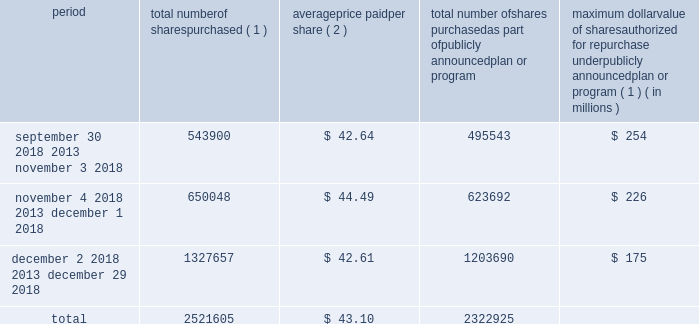Issuer purchases of equity securities in january 2017 , our board of directors authorized the repurchase of shares of our common stock with a value of up to $ 525 million in the aggregate .
As of december 29 , 2018 , $ 175 million remained available under this authorization .
In february 2019 , our board of directors authorized the additional repurchase of shares of our common stock with a value of up to $ 500.0 million in the aggregate .
The actual timing and amount of repurchases are subject to business and market conditions , corporate and regulatory requirements , stock price , acquisition opportunities and other factors .
The table presents repurchases made under our current authorization and shares surrendered by employees to satisfy income tax withholding obligations during the three months ended december 29 , 2018 : period total number of shares purchased ( 1 ) average price paid per share ( 2 ) total number of shares purchased as part of publicly announced plan or program maximum dollar value of shares authorized for repurchase under publicly announced plan or program ( 1 ) ( in millions ) september 30 , 2018 2013 november 3 , 2018 543900 $ 42.64 495543 $ 254 november 4 , 2018 2013 december 1 , 2018 650048 $ 44.49 623692 $ 226 december 2 , 2018 2013 december 29 , 2018 1327657 $ 42.61 1203690 $ 175 .
( 1 ) shares purchased that were not part of our publicly announced repurchase programs represent employee surrender of shares of restricted stock to satisfy employee income tax withholding obligations due upon vesting , and do not reduce the dollar value that may yet be purchased under our publicly announced repurchase programs .
( 2 ) the weighted average price paid per share of common stock does not include the cost of commissions. .
What is the total cash outflow for stock repurchase in the last three months of 2018 , ( in millions ) ? 
Computations: (2521605 * 43.10)
Answer: 108681175.5. 